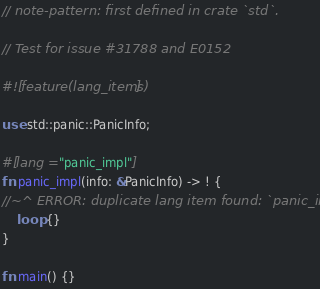<code> <loc_0><loc_0><loc_500><loc_500><_Rust_>// note-pattern: first defined in crate `std`.

// Test for issue #31788 and E0152

#![feature(lang_items)]

use std::panic::PanicInfo;

#[lang = "panic_impl"]
fn panic_impl(info: &PanicInfo) -> ! {
//~^ ERROR: duplicate lang item found: `panic_impl`.
    loop {}
}

fn main() {}
</code> 